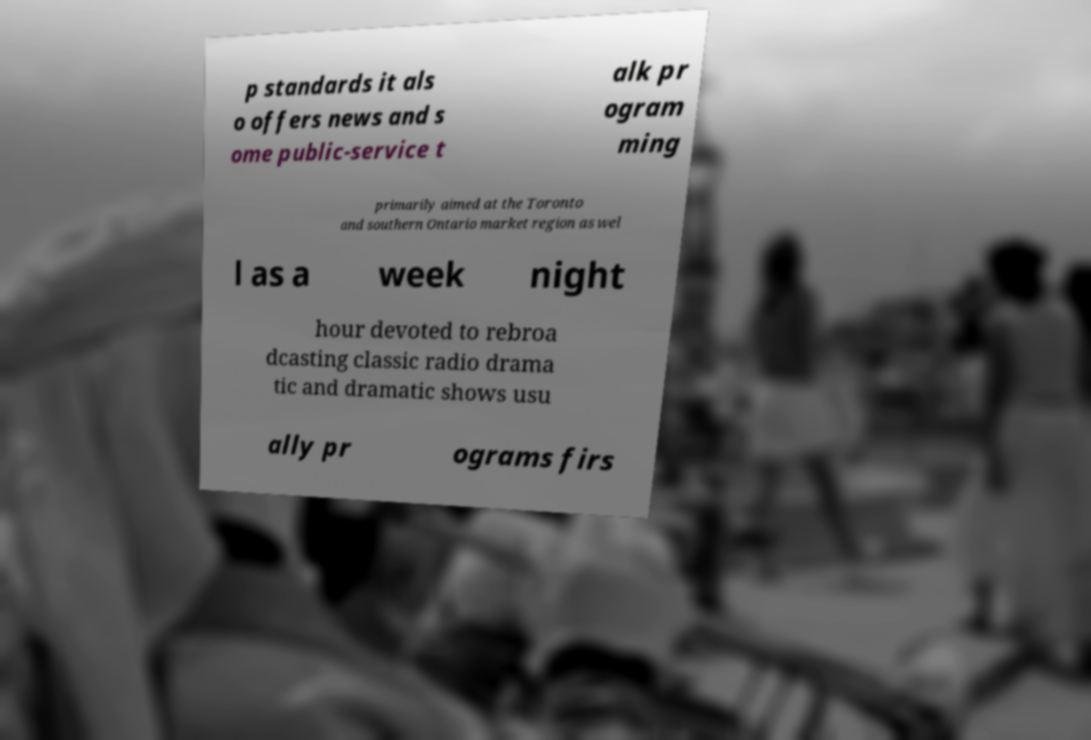Can you read and provide the text displayed in the image?This photo seems to have some interesting text. Can you extract and type it out for me? p standards it als o offers news and s ome public-service t alk pr ogram ming primarily aimed at the Toronto and southern Ontario market region as wel l as a week night hour devoted to rebroa dcasting classic radio drama tic and dramatic shows usu ally pr ograms firs 